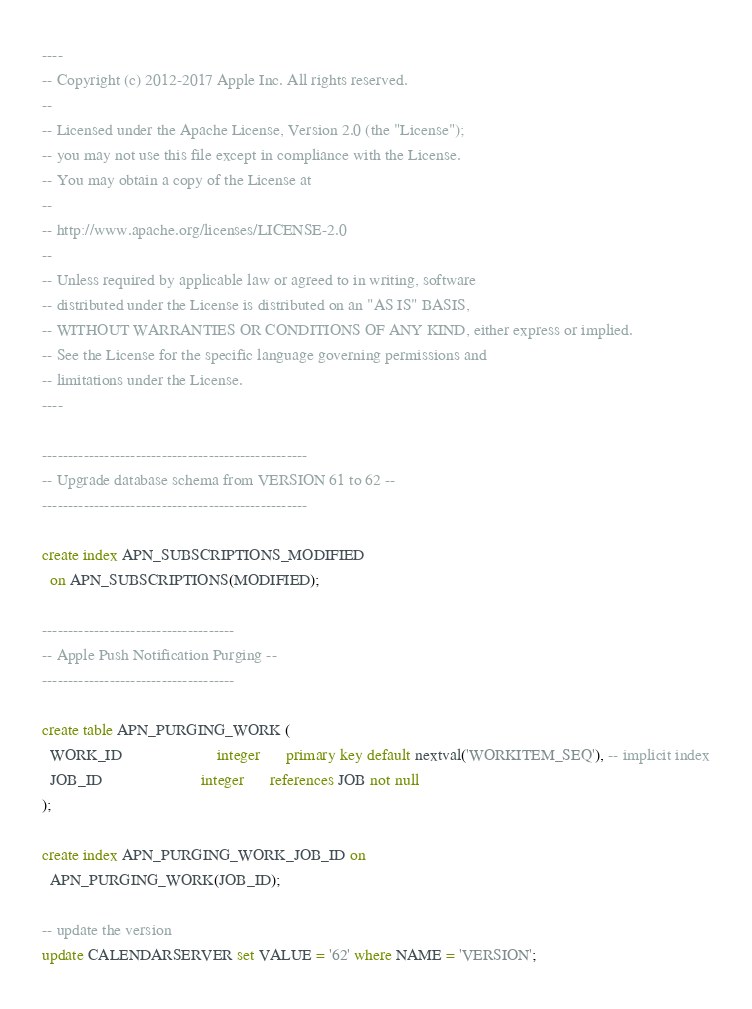Convert code to text. <code><loc_0><loc_0><loc_500><loc_500><_SQL_>----
-- Copyright (c) 2012-2017 Apple Inc. All rights reserved.
--
-- Licensed under the Apache License, Version 2.0 (the "License");
-- you may not use this file except in compliance with the License.
-- You may obtain a copy of the License at
--
-- http://www.apache.org/licenses/LICENSE-2.0
--
-- Unless required by applicable law or agreed to in writing, software
-- distributed under the License is distributed on an "AS IS" BASIS,
-- WITHOUT WARRANTIES OR CONDITIONS OF ANY KIND, either express or implied.
-- See the License for the specific language governing permissions and
-- limitations under the License.
----

---------------------------------------------------
-- Upgrade database schema from VERSION 61 to 62 --
---------------------------------------------------

create index APN_SUBSCRIPTIONS_MODIFIED
  on APN_SUBSCRIPTIONS(MODIFIED);

-------------------------------------
-- Apple Push Notification Purging --
-------------------------------------

create table APN_PURGING_WORK (
  WORK_ID                       integer      primary key default nextval('WORKITEM_SEQ'), -- implicit index
  JOB_ID                        integer      references JOB not null
);

create index APN_PURGING_WORK_JOB_ID on
  APN_PURGING_WORK(JOB_ID);

-- update the version
update CALENDARSERVER set VALUE = '62' where NAME = 'VERSION';
</code> 